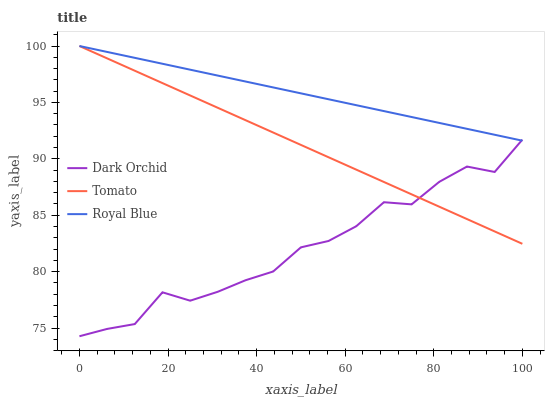Does Dark Orchid have the minimum area under the curve?
Answer yes or no. Yes. Does Royal Blue have the maximum area under the curve?
Answer yes or no. Yes. Does Royal Blue have the minimum area under the curve?
Answer yes or no. No. Does Dark Orchid have the maximum area under the curve?
Answer yes or no. No. Is Tomato the smoothest?
Answer yes or no. Yes. Is Dark Orchid the roughest?
Answer yes or no. Yes. Is Royal Blue the smoothest?
Answer yes or no. No. Is Royal Blue the roughest?
Answer yes or no. No. Does Dark Orchid have the lowest value?
Answer yes or no. Yes. Does Royal Blue have the lowest value?
Answer yes or no. No. Does Royal Blue have the highest value?
Answer yes or no. Yes. Does Dark Orchid have the highest value?
Answer yes or no. No. Does Dark Orchid intersect Tomato?
Answer yes or no. Yes. Is Dark Orchid less than Tomato?
Answer yes or no. No. Is Dark Orchid greater than Tomato?
Answer yes or no. No. 